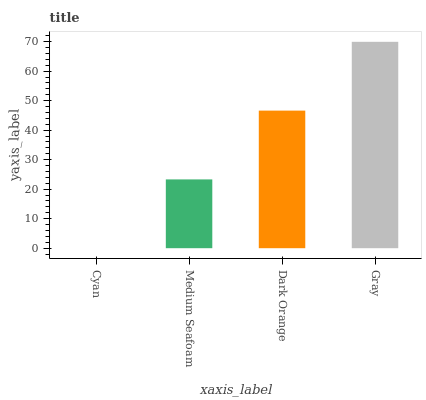Is Medium Seafoam the minimum?
Answer yes or no. No. Is Medium Seafoam the maximum?
Answer yes or no. No. Is Medium Seafoam greater than Cyan?
Answer yes or no. Yes. Is Cyan less than Medium Seafoam?
Answer yes or no. Yes. Is Cyan greater than Medium Seafoam?
Answer yes or no. No. Is Medium Seafoam less than Cyan?
Answer yes or no. No. Is Dark Orange the high median?
Answer yes or no. Yes. Is Medium Seafoam the low median?
Answer yes or no. Yes. Is Medium Seafoam the high median?
Answer yes or no. No. Is Gray the low median?
Answer yes or no. No. 